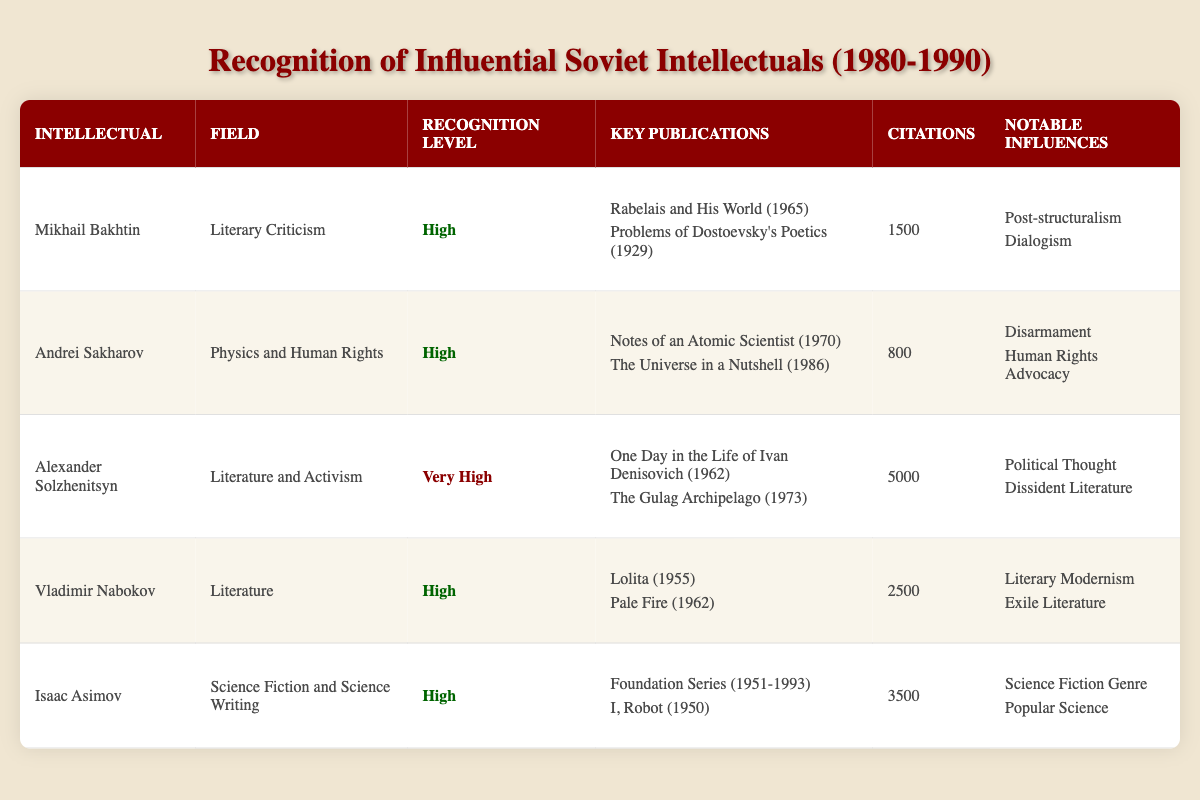What is the recognition level of Alexander Solzhenitsyn? Alexander Solzhenitsyn is listed in the table, and his recognition level is marked as "Very High."
Answer: Very High How many citations does Mikhail Bakhtin have? Looking at the table, the entry for Mikhail Bakhtin shows that he has 1500 citations.
Answer: 1500 Which intellectual has the highest number of citations? By examining the citation counts in the table, Alexander Solzhenitsyn has the highest at 5000 citations.
Answer: Alexander Solzhenitsyn What is the average number of citations for those recognized as 'High'? To calculate the average for the "High" recognition level: Mikhail Bakhtin (1500) + Andrei Sakharov (800) + Vladimir Nabokov (2500) + Isaac Asimov (3500) = 8300. There are 4 individuals, so 8300/4 = 2075.
Answer: 2075 Does Isaac Asimov have any notable influences listed? In the table, Isaac Asimov has notable influences: "Science Fiction Genre" and "Popular Science." Therefore, the answer is yes.
Answer: Yes Which two intellectuals are notable for their contributions to the field of literature? By reviewing the table, both Alexander Solzhenitsyn and Vladimir Nabokov are identified under the field of literature.
Answer: Alexander Solzhenitsyn and Vladimir Nabokov What publication did Andrei Sakharov release in 1986? In the table, Andrei Sakharov's key publications list "The Universe in a Nutshell" as released in 1986.
Answer: The Universe in a Nutshell Is there any intellectual listed that has a recognition level classified as 'Low'? The table does not include any intellectual with a recognition level classified as 'Low.' Therefore, the answer is no.
Answer: No Which field has the most intellectuals recognized at a "High" level? Assessing the table, we see three intellectuals (Mikhail Bakhtin, Andrei Sakharov, and Vladimir Nabokov) are in the "High" recognition level, indicating that multiple fields have representation. However, the data does not specify fields for recognition comparison. Thus, we can't definitively state a field based solely on counts from this data.
Answer: N/A 